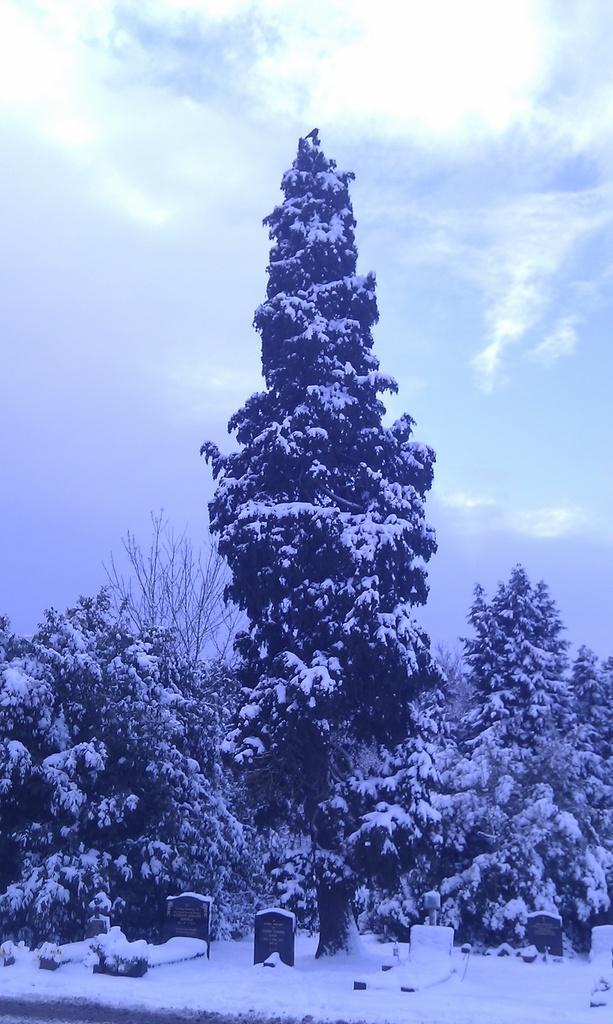In one or two sentences, can you explain what this image depicts? In this image, we can see trees covered with snow. At the bottom, we can see few cemeteries and snow. Background there is a sky. 